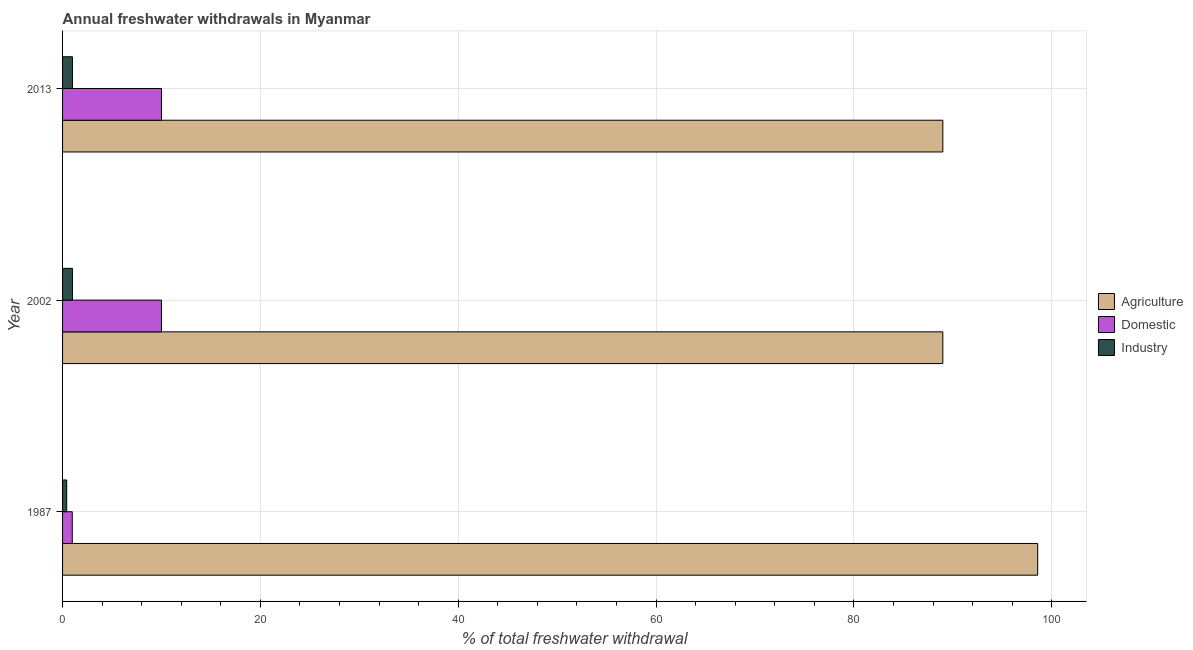How many groups of bars are there?
Make the answer very short. 3. Are the number of bars per tick equal to the number of legend labels?
Keep it short and to the point. Yes. Are the number of bars on each tick of the Y-axis equal?
Offer a very short reply. Yes. How many bars are there on the 1st tick from the top?
Offer a very short reply. 3. How many bars are there on the 3rd tick from the bottom?
Provide a short and direct response. 3. What is the label of the 2nd group of bars from the top?
Your answer should be very brief. 2002. In how many cases, is the number of bars for a given year not equal to the number of legend labels?
Your answer should be compact. 0. What is the percentage of freshwater withdrawal for agriculture in 1987?
Make the answer very short. 98.58. Across all years, what is the minimum percentage of freshwater withdrawal for domestic purposes?
Offer a terse response. 0.98. In which year was the percentage of freshwater withdrawal for industry maximum?
Offer a very short reply. 2002. In which year was the percentage of freshwater withdrawal for domestic purposes minimum?
Your response must be concise. 1987. What is the total percentage of freshwater withdrawal for industry in the graph?
Offer a terse response. 2.42. What is the difference between the percentage of freshwater withdrawal for industry in 1987 and the percentage of freshwater withdrawal for domestic purposes in 2002?
Make the answer very short. -9.58. What is the average percentage of freshwater withdrawal for domestic purposes per year?
Provide a succinct answer. 6.99. In the year 1987, what is the difference between the percentage of freshwater withdrawal for industry and percentage of freshwater withdrawal for domestic purposes?
Give a very brief answer. -0.56. In how many years, is the percentage of freshwater withdrawal for domestic purposes greater than 8 %?
Your answer should be very brief. 2. What is the ratio of the percentage of freshwater withdrawal for agriculture in 1987 to that in 2013?
Provide a succinct answer. 1.11. What is the difference between the highest and the second highest percentage of freshwater withdrawal for industry?
Provide a short and direct response. 0. What is the difference between the highest and the lowest percentage of freshwater withdrawal for industry?
Give a very brief answer. 0.58. In how many years, is the percentage of freshwater withdrawal for agriculture greater than the average percentage of freshwater withdrawal for agriculture taken over all years?
Give a very brief answer. 1. Is the sum of the percentage of freshwater withdrawal for industry in 2002 and 2013 greater than the maximum percentage of freshwater withdrawal for domestic purposes across all years?
Offer a very short reply. No. What does the 2nd bar from the top in 1987 represents?
Offer a terse response. Domestic. What does the 1st bar from the bottom in 1987 represents?
Offer a terse response. Agriculture. Is it the case that in every year, the sum of the percentage of freshwater withdrawal for agriculture and percentage of freshwater withdrawal for domestic purposes is greater than the percentage of freshwater withdrawal for industry?
Your answer should be very brief. Yes. How many bars are there?
Provide a short and direct response. 9. Does the graph contain any zero values?
Keep it short and to the point. No. How are the legend labels stacked?
Your answer should be compact. Vertical. What is the title of the graph?
Make the answer very short. Annual freshwater withdrawals in Myanmar. What is the label or title of the X-axis?
Offer a very short reply. % of total freshwater withdrawal. What is the % of total freshwater withdrawal in Agriculture in 1987?
Provide a short and direct response. 98.58. What is the % of total freshwater withdrawal in Domestic in 1987?
Your answer should be very brief. 0.98. What is the % of total freshwater withdrawal of Industry in 1987?
Your answer should be compact. 0.42. What is the % of total freshwater withdrawal in Agriculture in 2002?
Provide a short and direct response. 88.99. What is the % of total freshwater withdrawal in Domestic in 2002?
Keep it short and to the point. 10. What is the % of total freshwater withdrawal of Industry in 2002?
Your response must be concise. 1. What is the % of total freshwater withdrawal in Agriculture in 2013?
Offer a terse response. 88.99. Across all years, what is the maximum % of total freshwater withdrawal of Agriculture?
Your answer should be very brief. 98.58. Across all years, what is the maximum % of total freshwater withdrawal in Domestic?
Your answer should be compact. 10. Across all years, what is the minimum % of total freshwater withdrawal in Agriculture?
Ensure brevity in your answer.  88.99. Across all years, what is the minimum % of total freshwater withdrawal in Domestic?
Offer a very short reply. 0.98. Across all years, what is the minimum % of total freshwater withdrawal of Industry?
Your answer should be compact. 0.42. What is the total % of total freshwater withdrawal of Agriculture in the graph?
Your response must be concise. 276.56. What is the total % of total freshwater withdrawal of Domestic in the graph?
Make the answer very short. 20.98. What is the total % of total freshwater withdrawal in Industry in the graph?
Keep it short and to the point. 2.42. What is the difference between the % of total freshwater withdrawal in Agriculture in 1987 and that in 2002?
Provide a succinct answer. 9.59. What is the difference between the % of total freshwater withdrawal in Domestic in 1987 and that in 2002?
Provide a short and direct response. -9.02. What is the difference between the % of total freshwater withdrawal of Industry in 1987 and that in 2002?
Offer a very short reply. -0.58. What is the difference between the % of total freshwater withdrawal in Agriculture in 1987 and that in 2013?
Your answer should be very brief. 9.59. What is the difference between the % of total freshwater withdrawal of Domestic in 1987 and that in 2013?
Give a very brief answer. -9.02. What is the difference between the % of total freshwater withdrawal of Industry in 1987 and that in 2013?
Keep it short and to the point. -0.58. What is the difference between the % of total freshwater withdrawal in Domestic in 2002 and that in 2013?
Your response must be concise. 0. What is the difference between the % of total freshwater withdrawal in Agriculture in 1987 and the % of total freshwater withdrawal in Domestic in 2002?
Provide a short and direct response. 88.58. What is the difference between the % of total freshwater withdrawal of Agriculture in 1987 and the % of total freshwater withdrawal of Industry in 2002?
Make the answer very short. 97.58. What is the difference between the % of total freshwater withdrawal in Domestic in 1987 and the % of total freshwater withdrawal in Industry in 2002?
Your answer should be very brief. -0.02. What is the difference between the % of total freshwater withdrawal in Agriculture in 1987 and the % of total freshwater withdrawal in Domestic in 2013?
Your answer should be compact. 88.58. What is the difference between the % of total freshwater withdrawal of Agriculture in 1987 and the % of total freshwater withdrawal of Industry in 2013?
Your answer should be very brief. 97.58. What is the difference between the % of total freshwater withdrawal in Domestic in 1987 and the % of total freshwater withdrawal in Industry in 2013?
Your response must be concise. -0.02. What is the difference between the % of total freshwater withdrawal of Agriculture in 2002 and the % of total freshwater withdrawal of Domestic in 2013?
Your answer should be compact. 78.99. What is the difference between the % of total freshwater withdrawal in Agriculture in 2002 and the % of total freshwater withdrawal in Industry in 2013?
Offer a terse response. 87.99. What is the average % of total freshwater withdrawal in Agriculture per year?
Offer a terse response. 92.19. What is the average % of total freshwater withdrawal of Domestic per year?
Offer a terse response. 6.99. What is the average % of total freshwater withdrawal of Industry per year?
Your answer should be very brief. 0.81. In the year 1987, what is the difference between the % of total freshwater withdrawal of Agriculture and % of total freshwater withdrawal of Domestic?
Provide a succinct answer. 97.6. In the year 1987, what is the difference between the % of total freshwater withdrawal of Agriculture and % of total freshwater withdrawal of Industry?
Your response must be concise. 98.16. In the year 1987, what is the difference between the % of total freshwater withdrawal of Domestic and % of total freshwater withdrawal of Industry?
Ensure brevity in your answer.  0.56. In the year 2002, what is the difference between the % of total freshwater withdrawal in Agriculture and % of total freshwater withdrawal in Domestic?
Keep it short and to the point. 78.99. In the year 2002, what is the difference between the % of total freshwater withdrawal of Agriculture and % of total freshwater withdrawal of Industry?
Ensure brevity in your answer.  87.99. In the year 2002, what is the difference between the % of total freshwater withdrawal of Domestic and % of total freshwater withdrawal of Industry?
Provide a short and direct response. 9. In the year 2013, what is the difference between the % of total freshwater withdrawal in Agriculture and % of total freshwater withdrawal in Domestic?
Your answer should be compact. 78.99. In the year 2013, what is the difference between the % of total freshwater withdrawal of Agriculture and % of total freshwater withdrawal of Industry?
Offer a very short reply. 87.99. What is the ratio of the % of total freshwater withdrawal of Agriculture in 1987 to that in 2002?
Give a very brief answer. 1.11. What is the ratio of the % of total freshwater withdrawal in Domestic in 1987 to that in 2002?
Keep it short and to the point. 0.1. What is the ratio of the % of total freshwater withdrawal of Industry in 1987 to that in 2002?
Provide a short and direct response. 0.42. What is the ratio of the % of total freshwater withdrawal of Agriculture in 1987 to that in 2013?
Keep it short and to the point. 1.11. What is the ratio of the % of total freshwater withdrawal of Domestic in 1987 to that in 2013?
Your answer should be compact. 0.1. What is the ratio of the % of total freshwater withdrawal of Industry in 1987 to that in 2013?
Give a very brief answer. 0.42. What is the ratio of the % of total freshwater withdrawal in Agriculture in 2002 to that in 2013?
Provide a succinct answer. 1. What is the ratio of the % of total freshwater withdrawal in Domestic in 2002 to that in 2013?
Make the answer very short. 1. What is the ratio of the % of total freshwater withdrawal in Industry in 2002 to that in 2013?
Make the answer very short. 1. What is the difference between the highest and the second highest % of total freshwater withdrawal in Agriculture?
Your answer should be compact. 9.59. What is the difference between the highest and the second highest % of total freshwater withdrawal in Domestic?
Make the answer very short. 0. What is the difference between the highest and the lowest % of total freshwater withdrawal of Agriculture?
Offer a very short reply. 9.59. What is the difference between the highest and the lowest % of total freshwater withdrawal in Domestic?
Make the answer very short. 9.02. What is the difference between the highest and the lowest % of total freshwater withdrawal in Industry?
Provide a succinct answer. 0.58. 